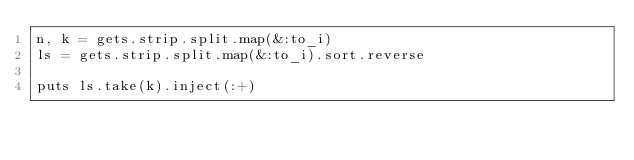Convert code to text. <code><loc_0><loc_0><loc_500><loc_500><_Ruby_>n, k = gets.strip.split.map(&:to_i)
ls = gets.strip.split.map(&:to_i).sort.reverse

puts ls.take(k).inject(:+)
</code> 